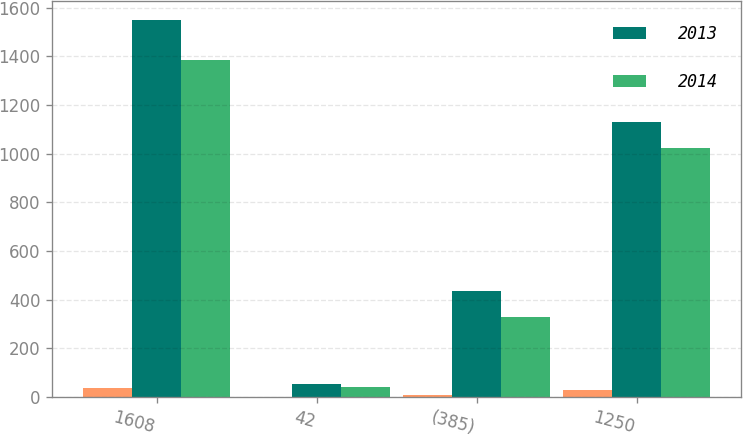Convert chart. <chart><loc_0><loc_0><loc_500><loc_500><stacked_bar_chart><ecel><fcel>1608<fcel>42<fcel>(385)<fcel>1250<nl><fcel>nan<fcel>35<fcel>1<fcel>8<fcel>27<nl><fcel>2013<fcel>1549<fcel>51<fcel>434<fcel>1131<nl><fcel>2014<fcel>1383<fcel>39<fcel>329<fcel>1022<nl></chart> 